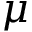Convert formula to latex. <formula><loc_0><loc_0><loc_500><loc_500>\mu</formula> 